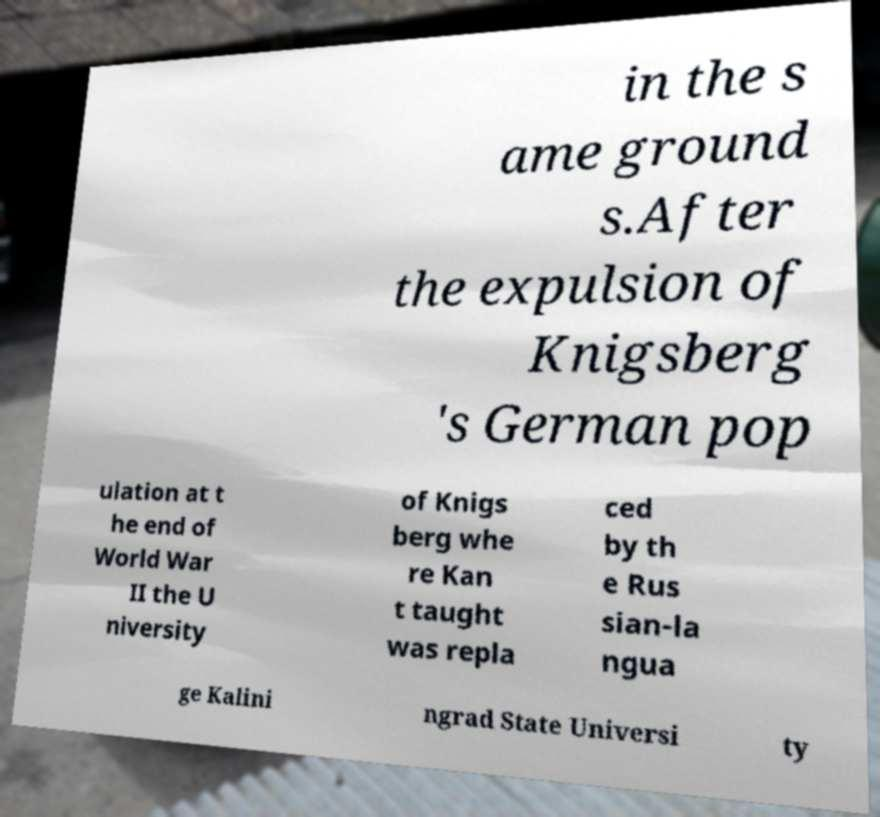Please read and relay the text visible in this image. What does it say? in the s ame ground s.After the expulsion of Knigsberg 's German pop ulation at t he end of World War II the U niversity of Knigs berg whe re Kan t taught was repla ced by th e Rus sian-la ngua ge Kalini ngrad State Universi ty 